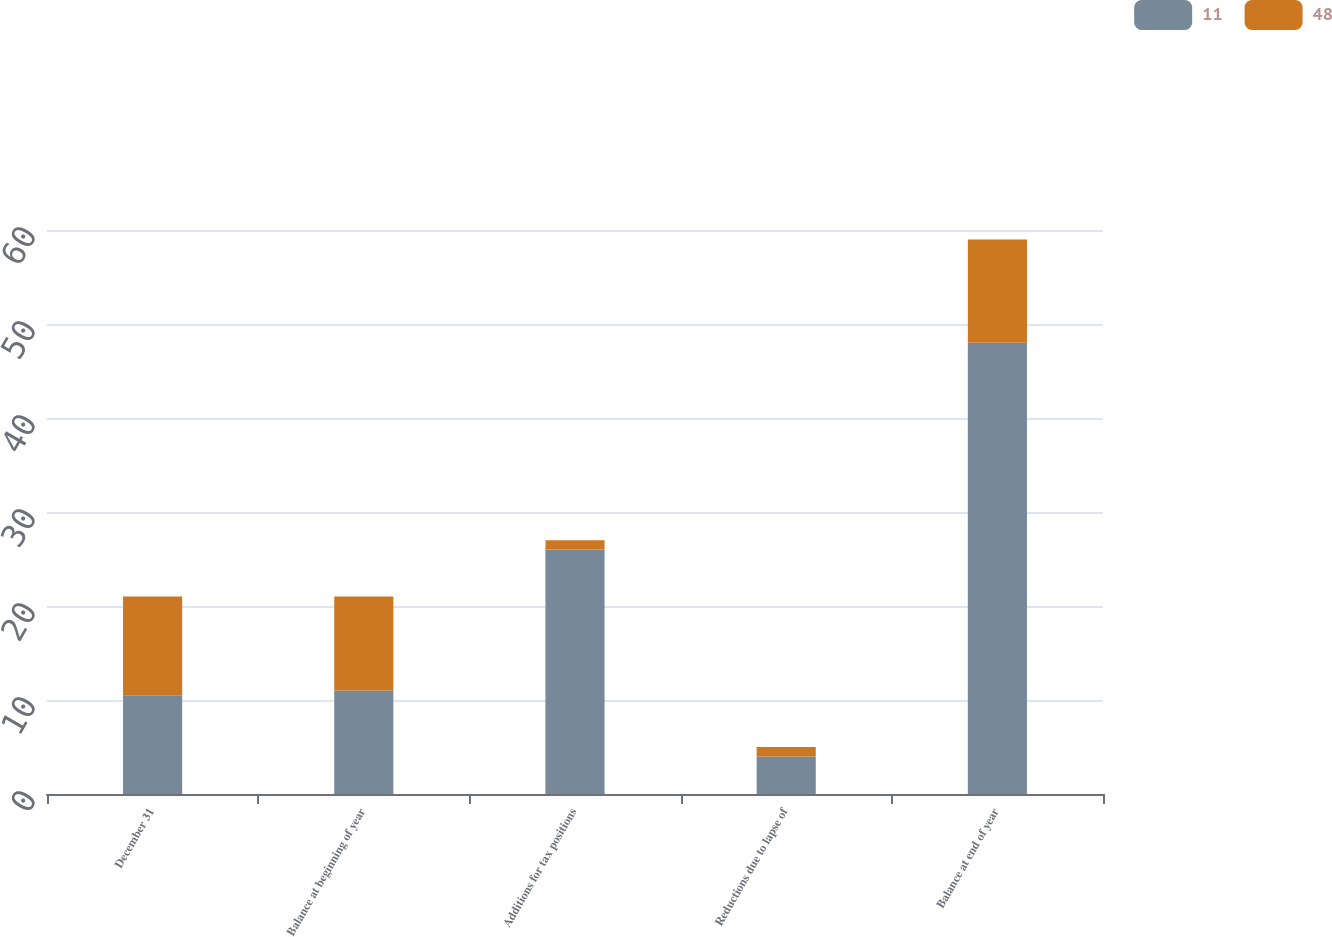Convert chart to OTSL. <chart><loc_0><loc_0><loc_500><loc_500><stacked_bar_chart><ecel><fcel>December 31<fcel>Balance at beginning of year<fcel>Additions for tax positions<fcel>Reductions due to lapse of<fcel>Balance at end of year<nl><fcel>11<fcel>10.5<fcel>11<fcel>26<fcel>4<fcel>48<nl><fcel>48<fcel>10.5<fcel>10<fcel>1<fcel>1<fcel>11<nl></chart> 